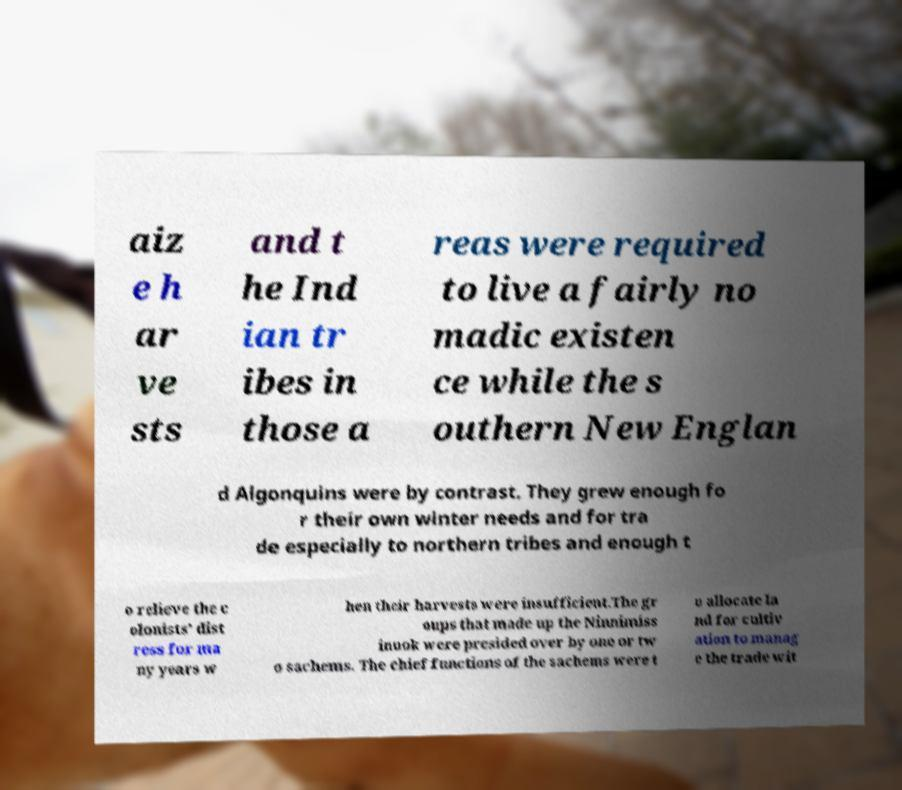Please identify and transcribe the text found in this image. aiz e h ar ve sts and t he Ind ian tr ibes in those a reas were required to live a fairly no madic existen ce while the s outhern New Englan d Algonquins were by contrast. They grew enough fo r their own winter needs and for tra de especially to northern tribes and enough t o relieve the c olonists' dist ress for ma ny years w hen their harvests were insufficient.The gr oups that made up the Ninnimiss inuok were presided over by one or tw o sachems. The chief functions of the sachems were t o allocate la nd for cultiv ation to manag e the trade wit 